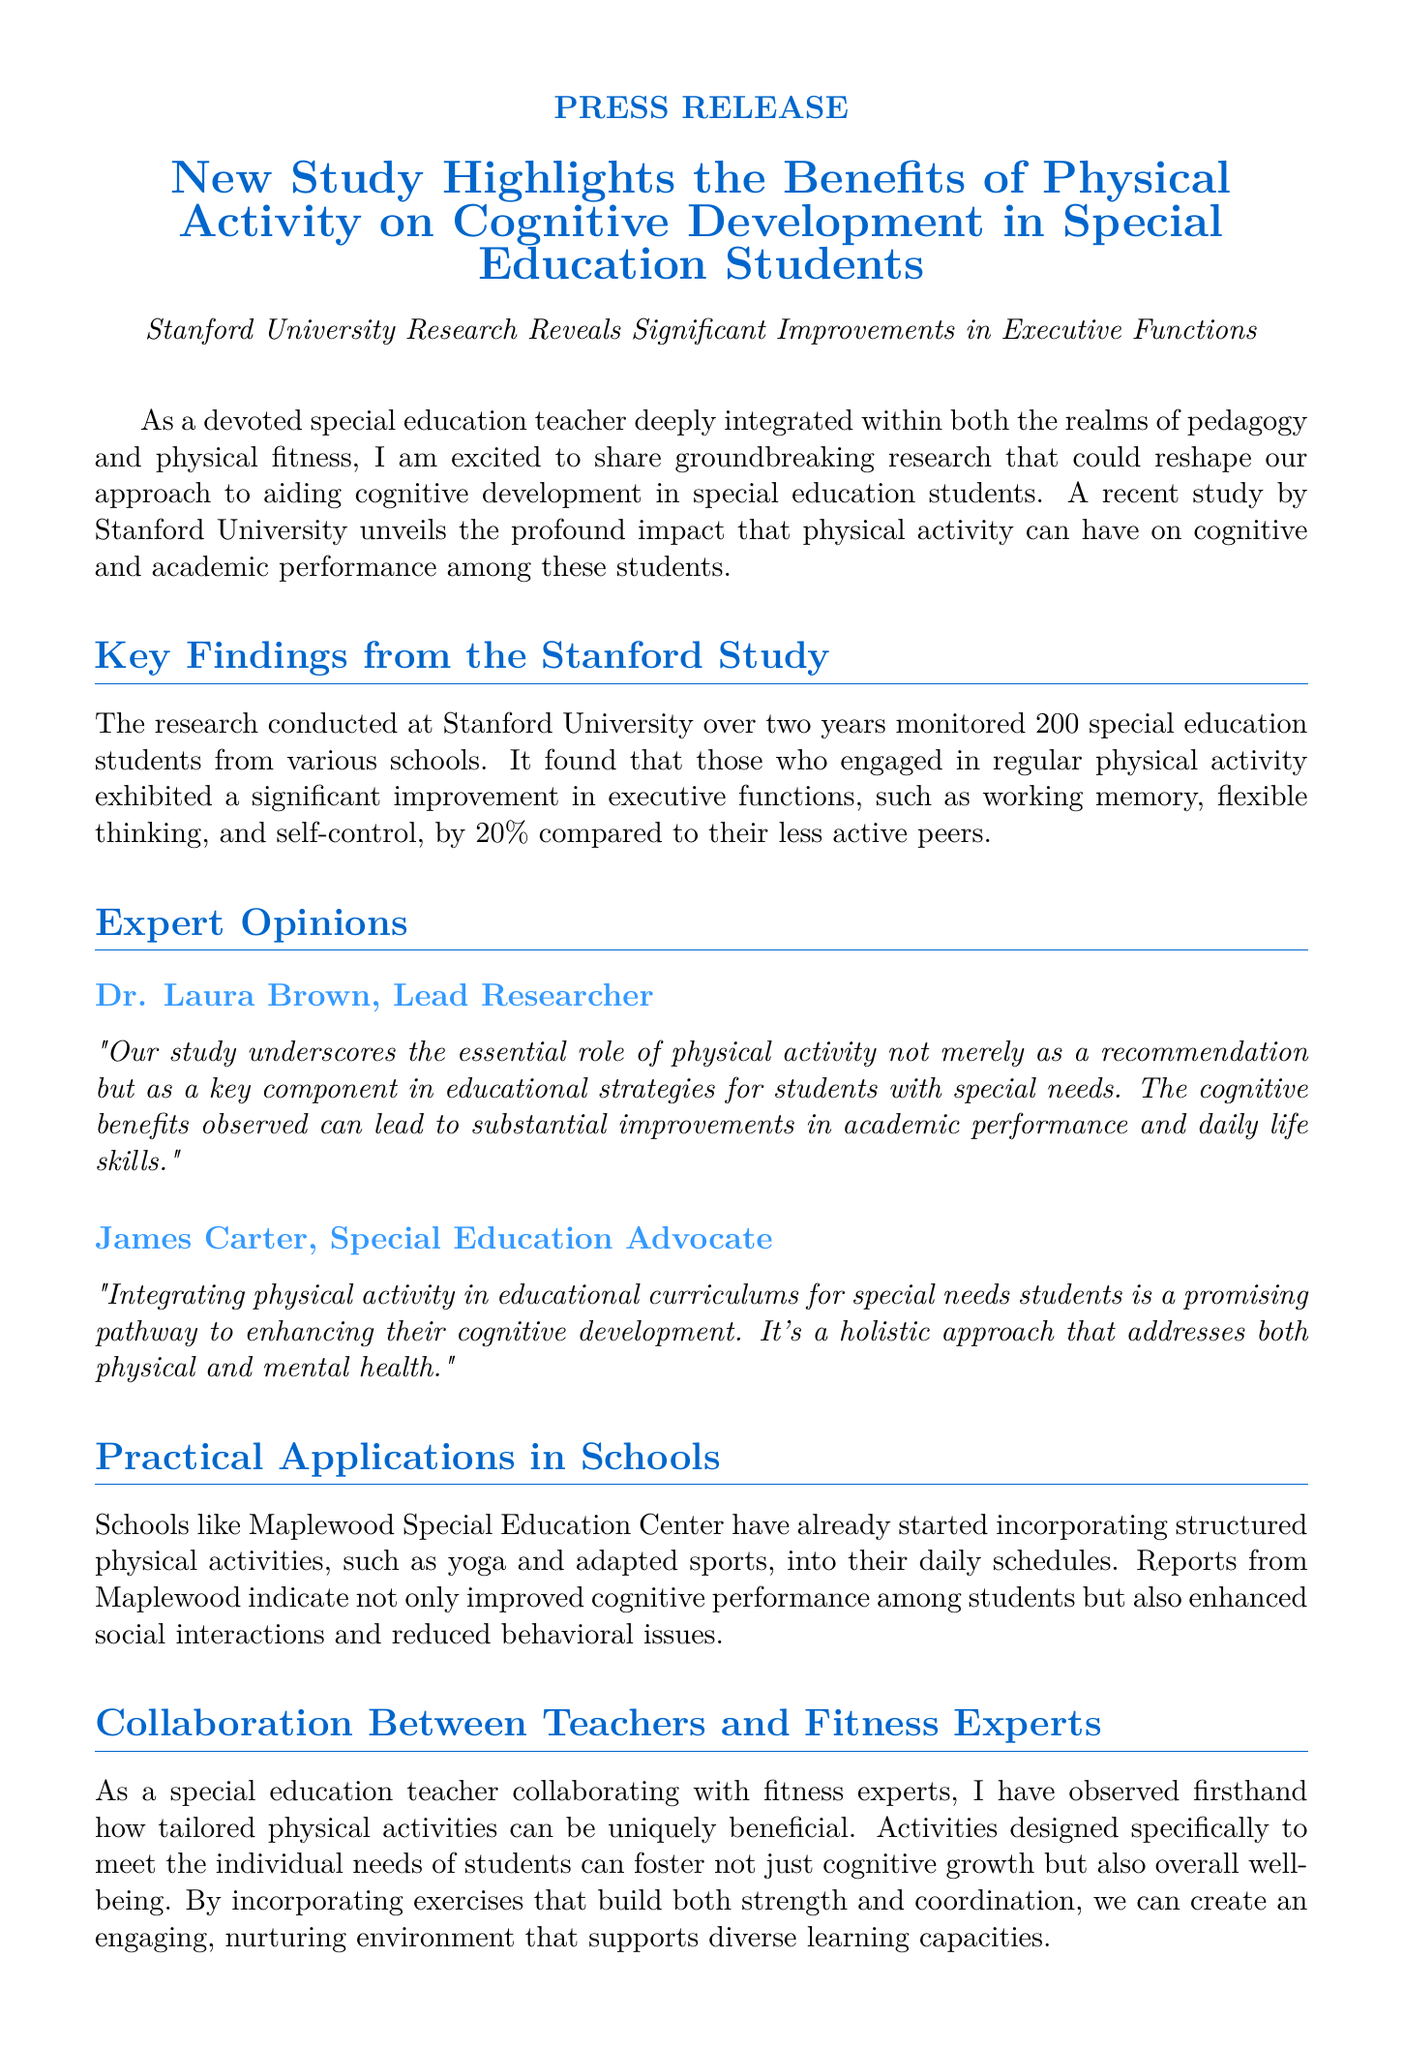What is the title of the study? The title can be found in the main heading of the document, which is "New Study Highlights the Benefits of Physical Activity on Cognitive Development in Special Education Students."
Answer: New Study Highlights the Benefits of Physical Activity on Cognitive Development in Special Education Students Who conducted the study? The document states that the research was conducted at Stanford University.
Answer: Stanford University How many students were monitored in the study? The document specifies that 200 special education students were monitored during the research.
Answer: 200 By what percentage did executive functions improve? The improvement percentage for executive functions is mentioned in the key findings as 20%.
Answer: 20% Who is the lead researcher mentioned? The lead researcher is cited in the expert opinions section as Dr. Laura Brown.
Answer: Dr. Laura Brown What school began incorporating structured physical activities? The document mentions Maplewood Special Education Center as a school that has started incorporating these activities.
Answer: Maplewood Special Education Center What kind of activities were included in the school's programs? The document lists yoga and adapted sports as examples of structured physical activities included.
Answer: Yoga and adapted sports What is the main call to action in the article? The document emphasizes the need for educators, administrators, and policymakers to harness physical activity for cognitive development in students.
Answer: Reimagining educational practices to include physical fitness What role does the special education teacher play according to the document? The text suggests that the special education teacher combines knowledge of pedagogy with fitness expertise to enhance student well-being.
Answer: Combines knowledge of pedagogy with fitness expertise 